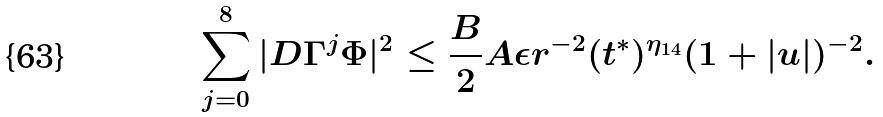Convert formula to latex. <formula><loc_0><loc_0><loc_500><loc_500>\sum _ { j = 0 } ^ { 8 } | D \Gamma ^ { j } \Phi | ^ { 2 } \leq \frac { B } { 2 } A \epsilon r ^ { - 2 } ( t ^ { * } ) ^ { \eta _ { 1 4 } } ( 1 + | u | ) ^ { - 2 } .</formula> 